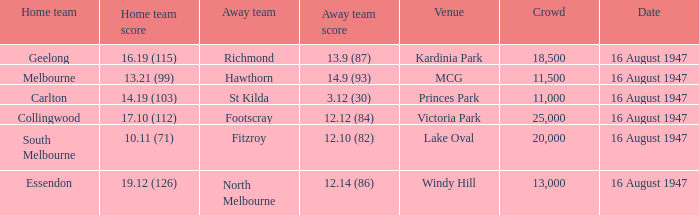How much did the away team score at victoria park? 12.12 (84). 